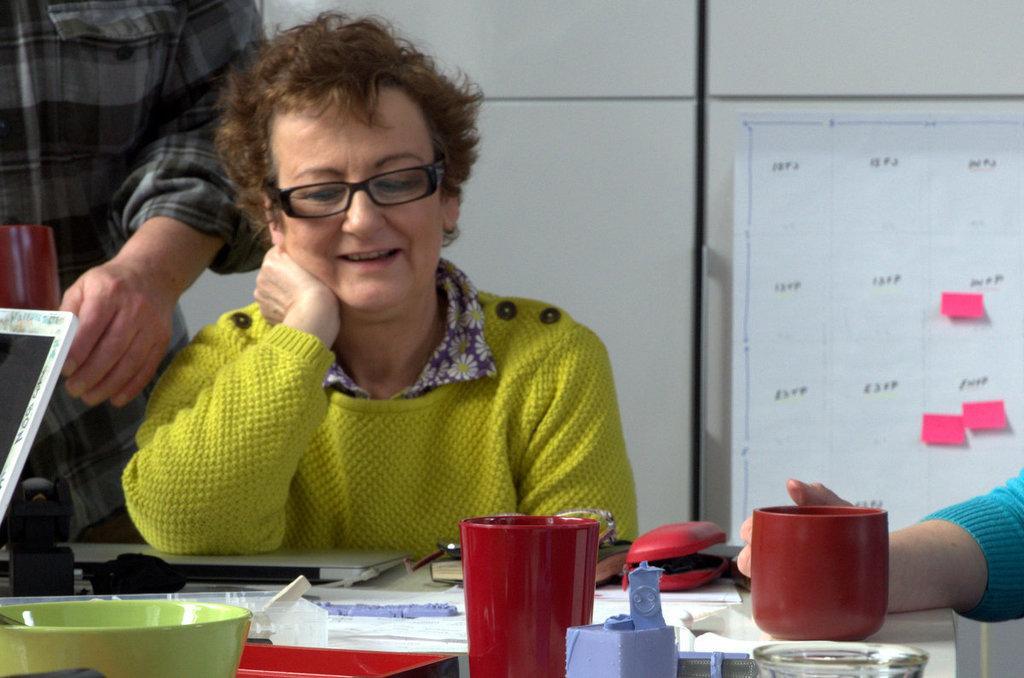How would you summarize this image in a sentence or two? In this image there are a few people sitting around the table, on the table there are laptops, glasses, bowls and some other objects, there is a chart attached to the wall. 